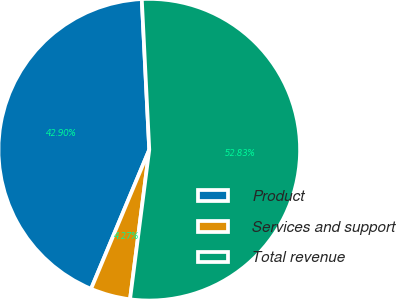<chart> <loc_0><loc_0><loc_500><loc_500><pie_chart><fcel>Product<fcel>Services and support<fcel>Total revenue<nl><fcel>42.9%<fcel>4.27%<fcel>52.82%<nl></chart> 